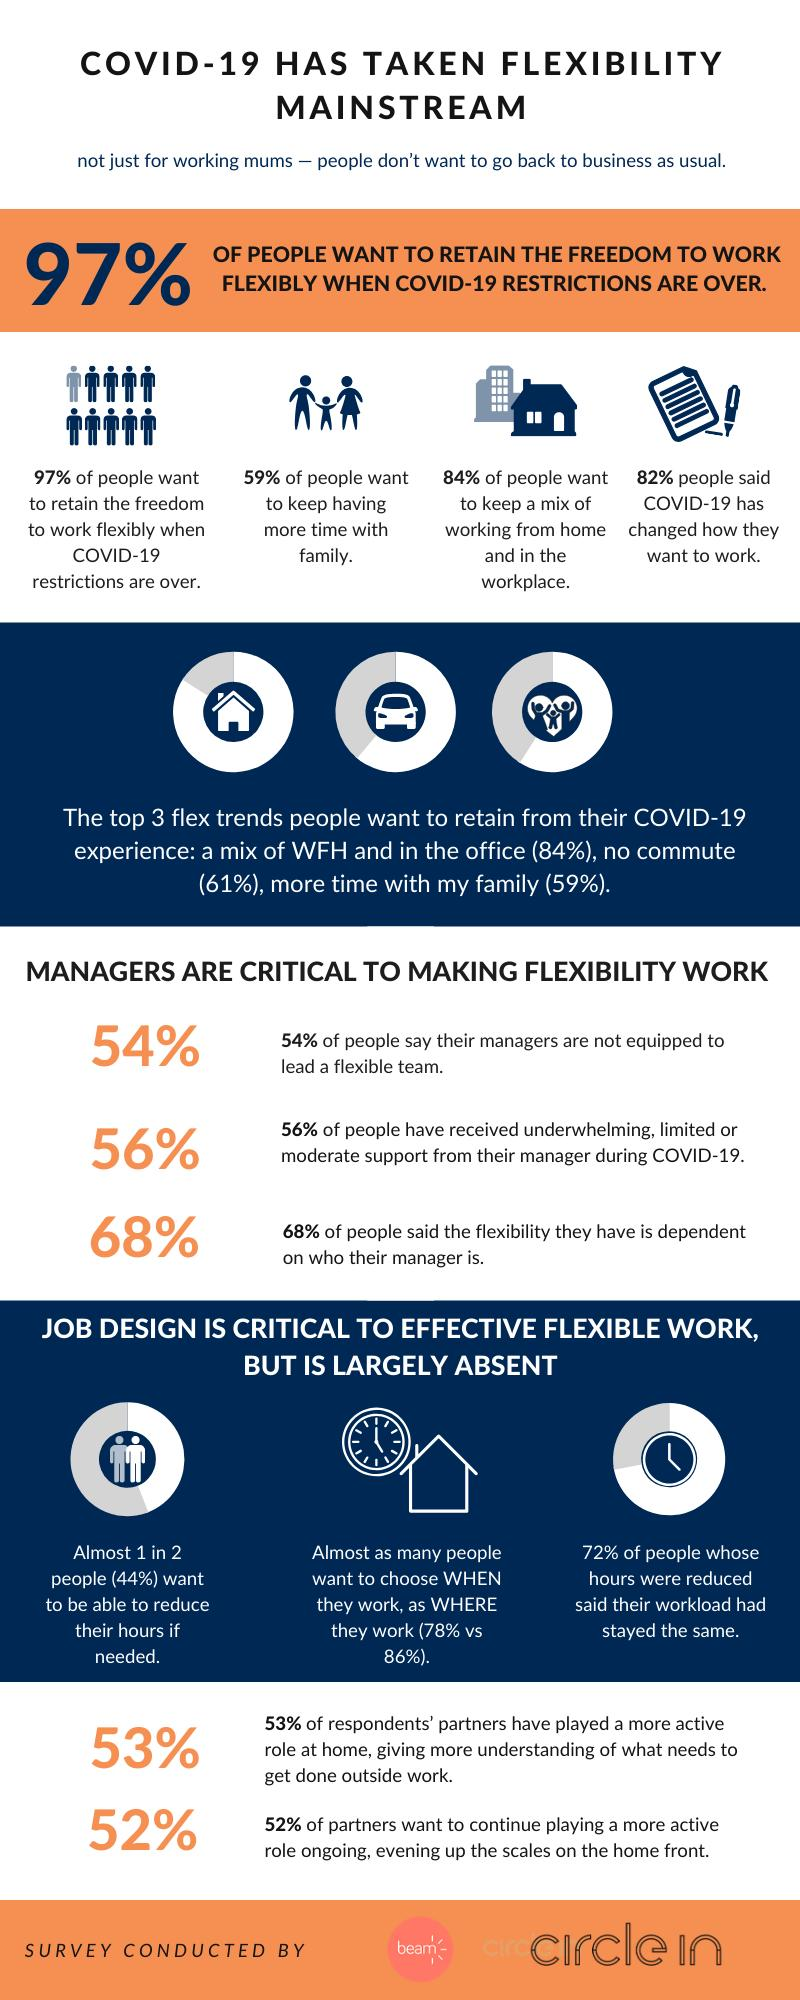Draw attention to some important aspects in this diagram. During the COVID-19 pandemic, commuters have been forced to adapt to new ways of working, and one of the trends that people have expressed a desire to retain is the option to work from home, or no commute, which was reported as the top flex trend with 61% of respondents. A majority of people, or 59%, want to continue spending time with their families. A survey conducted reveals that 72% of people believe that their workload has not changed. A higher percentage of people believe that flexibility is dependent on their manager's ability compared to those who think their manager is not equipped, which is 14%. When it comes to work, the clock and the house indicate that the choice between working and where to work is available to them. 